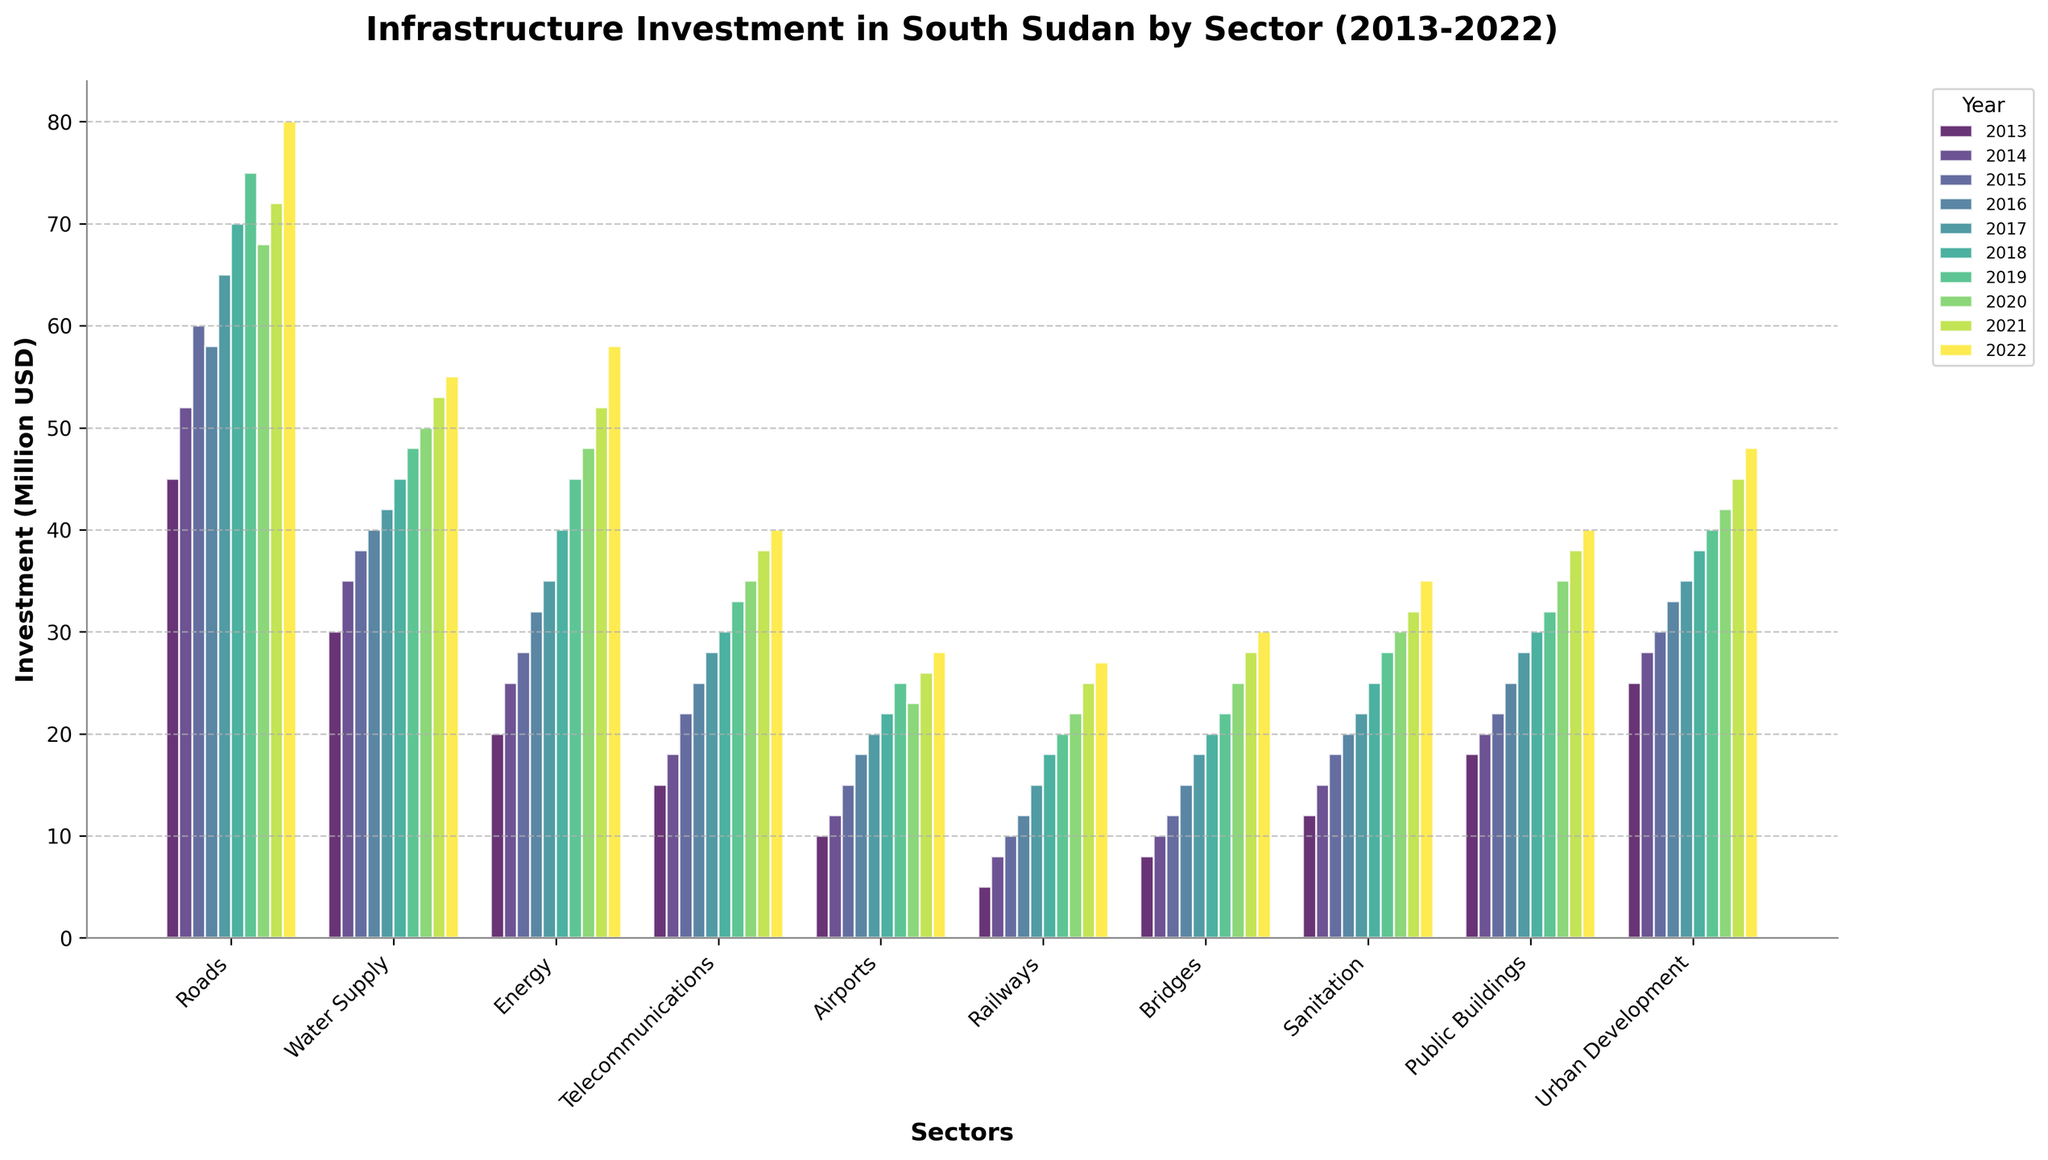What sector saw the highest investment in 2016? Looking at the bars corresponding to 2016, the sector with the tallest bar represents the highest investment. The tallest bar for 2016 is in the "Roads" sector.
Answer: Roads What is the difference in investment between Roads and Water Supply in 2022? Examine the height of the bars corresponding to Roads and Water Supply for the year 2022. The respective investments are 80 million USD and 55 million USD. The difference is 80 - 55.
Answer: 25 million USD Which sector showed the least growth in investment from 2013 to 2022? To determine the growth, subtract the 2013 value from the 2022 value for each sector and compare them. Railways: 27 - 5 = 22, which appears to be the smallest growth.
Answer: Railways Which year had the highest overall investment across all sectors combined? Add up the heights of all the bars for each year and compare the sums. 2022 has the highest combined investment.
Answer: 2022 Did any sector's investment decrease between any two consecutive years? Scan through each sector's bars to find any two consecutive years where the bar height decreases. The Roads sector shows a decrease from 2019 (75) to 2020 (68)
Answer: Yes, Roads between 2019 and 2020 What is the average yearly investment in the Energy sector over the decade? Add up the investment values for the Energy sector from 2013 to 2022 and divide by 10. (20+25+28+32+35+40+45+48+52+58)/10 = 38.3
Answer: 38.3 million USD How does the investment in Urban Development in 2020 compare to that in Telecommunications in 2020? Look at the heights of the bars corresponding to Urban Development and Telecommunications for 2020. Urban Development (42) is greater than Telecommunications (35).
Answer: Urban Development is greater Which sector had the highest increase in investment between 2013 and 2022? Subtract the 2013 value from the 2022 value for each sector and compare. Roads: 80 - 45 = 35, which is the highest increase.
Answer: Roads What visual trend can you observe in the Water Supply sector over the decade? Observe the increasing height of the bars for Water Supply from 2013 to 2022, indicating a continuous increase in investment.
Answer: Continuous increase How does the 2018 investment in Public Buildings compare with the 2018 investment in Sanitation? Look at the heights of the bars for Public Buildings and Sanitation in 2018. Both sectors have investments of 30 million USD, so they are equal.
Answer: They are equal 